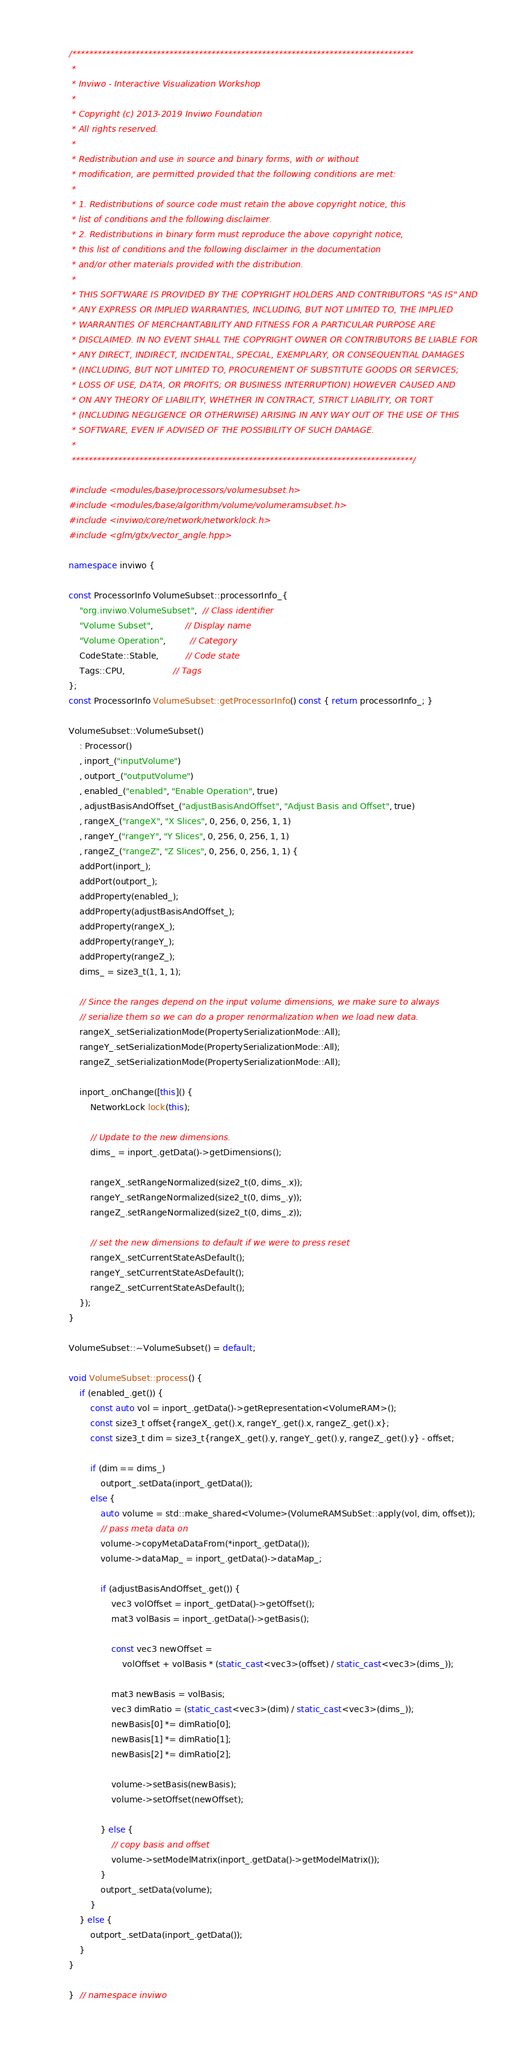<code> <loc_0><loc_0><loc_500><loc_500><_C++_>/*********************************************************************************
 *
 * Inviwo - Interactive Visualization Workshop
 *
 * Copyright (c) 2013-2019 Inviwo Foundation
 * All rights reserved.
 *
 * Redistribution and use in source and binary forms, with or without
 * modification, are permitted provided that the following conditions are met:
 *
 * 1. Redistributions of source code must retain the above copyright notice, this
 * list of conditions and the following disclaimer.
 * 2. Redistributions in binary form must reproduce the above copyright notice,
 * this list of conditions and the following disclaimer in the documentation
 * and/or other materials provided with the distribution.
 *
 * THIS SOFTWARE IS PROVIDED BY THE COPYRIGHT HOLDERS AND CONTRIBUTORS "AS IS" AND
 * ANY EXPRESS OR IMPLIED WARRANTIES, INCLUDING, BUT NOT LIMITED TO, THE IMPLIED
 * WARRANTIES OF MERCHANTABILITY AND FITNESS FOR A PARTICULAR PURPOSE ARE
 * DISCLAIMED. IN NO EVENT SHALL THE COPYRIGHT OWNER OR CONTRIBUTORS BE LIABLE FOR
 * ANY DIRECT, INDIRECT, INCIDENTAL, SPECIAL, EXEMPLARY, OR CONSEQUENTIAL DAMAGES
 * (INCLUDING, BUT NOT LIMITED TO, PROCUREMENT OF SUBSTITUTE GOODS OR SERVICES;
 * LOSS OF USE, DATA, OR PROFITS; OR BUSINESS INTERRUPTION) HOWEVER CAUSED AND
 * ON ANY THEORY OF LIABILITY, WHETHER IN CONTRACT, STRICT LIABILITY, OR TORT
 * (INCLUDING NEGLIGENCE OR OTHERWISE) ARISING IN ANY WAY OUT OF THE USE OF THIS
 * SOFTWARE, EVEN IF ADVISED OF THE POSSIBILITY OF SUCH DAMAGE.
 *
 *********************************************************************************/

#include <modules/base/processors/volumesubset.h>
#include <modules/base/algorithm/volume/volumeramsubset.h>
#include <inviwo/core/network/networklock.h>
#include <glm/gtx/vector_angle.hpp>

namespace inviwo {

const ProcessorInfo VolumeSubset::processorInfo_{
    "org.inviwo.VolumeSubset",  // Class identifier
    "Volume Subset",            // Display name
    "Volume Operation",         // Category
    CodeState::Stable,          // Code state
    Tags::CPU,                  // Tags
};
const ProcessorInfo VolumeSubset::getProcessorInfo() const { return processorInfo_; }

VolumeSubset::VolumeSubset()
    : Processor()
    , inport_("inputVolume")
    , outport_("outputVolume")
    , enabled_("enabled", "Enable Operation", true)
    , adjustBasisAndOffset_("adjustBasisAndOffset", "Adjust Basis and Offset", true)
    , rangeX_("rangeX", "X Slices", 0, 256, 0, 256, 1, 1)
    , rangeY_("rangeY", "Y Slices", 0, 256, 0, 256, 1, 1)
    , rangeZ_("rangeZ", "Z Slices", 0, 256, 0, 256, 1, 1) {
    addPort(inport_);
    addPort(outport_);
    addProperty(enabled_);
    addProperty(adjustBasisAndOffset_);
    addProperty(rangeX_);
    addProperty(rangeY_);
    addProperty(rangeZ_);
    dims_ = size3_t(1, 1, 1);

    // Since the ranges depend on the input volume dimensions, we make sure to always
    // serialize them so we can do a proper renormalization when we load new data.
    rangeX_.setSerializationMode(PropertySerializationMode::All);
    rangeY_.setSerializationMode(PropertySerializationMode::All);
    rangeZ_.setSerializationMode(PropertySerializationMode::All);

    inport_.onChange([this]() {
        NetworkLock lock(this);

        // Update to the new dimensions.
        dims_ = inport_.getData()->getDimensions();

        rangeX_.setRangeNormalized(size2_t(0, dims_.x));
        rangeY_.setRangeNormalized(size2_t(0, dims_.y));
        rangeZ_.setRangeNormalized(size2_t(0, dims_.z));

        // set the new dimensions to default if we were to press reset
        rangeX_.setCurrentStateAsDefault();
        rangeY_.setCurrentStateAsDefault();
        rangeZ_.setCurrentStateAsDefault();
    });
}

VolumeSubset::~VolumeSubset() = default;

void VolumeSubset::process() {
    if (enabled_.get()) {
        const auto vol = inport_.getData()->getRepresentation<VolumeRAM>();
        const size3_t offset{rangeX_.get().x, rangeY_.get().x, rangeZ_.get().x};
        const size3_t dim = size3_t{rangeX_.get().y, rangeY_.get().y, rangeZ_.get().y} - offset;

        if (dim == dims_)
            outport_.setData(inport_.getData());
        else {
            auto volume = std::make_shared<Volume>(VolumeRAMSubSet::apply(vol, dim, offset));
            // pass meta data on
            volume->copyMetaDataFrom(*inport_.getData());
            volume->dataMap_ = inport_.getData()->dataMap_;

            if (adjustBasisAndOffset_.get()) {
                vec3 volOffset = inport_.getData()->getOffset();
                mat3 volBasis = inport_.getData()->getBasis();

                const vec3 newOffset =
                    volOffset + volBasis * (static_cast<vec3>(offset) / static_cast<vec3>(dims_));

                mat3 newBasis = volBasis;
                vec3 dimRatio = (static_cast<vec3>(dim) / static_cast<vec3>(dims_));
                newBasis[0] *= dimRatio[0];
                newBasis[1] *= dimRatio[1];
                newBasis[2] *= dimRatio[2];

                volume->setBasis(newBasis);
                volume->setOffset(newOffset);

            } else {
                // copy basis and offset
                volume->setModelMatrix(inport_.getData()->getModelMatrix());
            }
            outport_.setData(volume);
        }
    } else {
        outport_.setData(inport_.getData());
    }
}

}  // namespace inviwo
</code> 